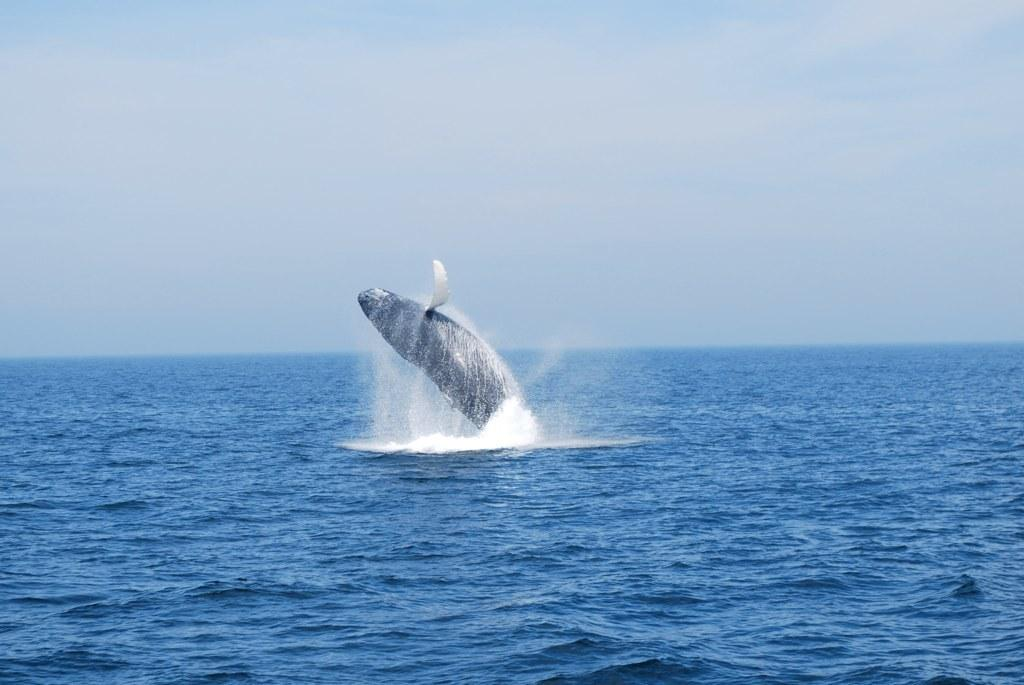What is the main subject in the image? There is a whale in the image. What is the setting of the image? The image features water and the sky is visible in the background. Can you describe the whale in the image? The whale is the main subject in the image. What route does the whale take to reach the morning tray in the image? There is no morning tray present in the image, and therefore no route can be determined. 